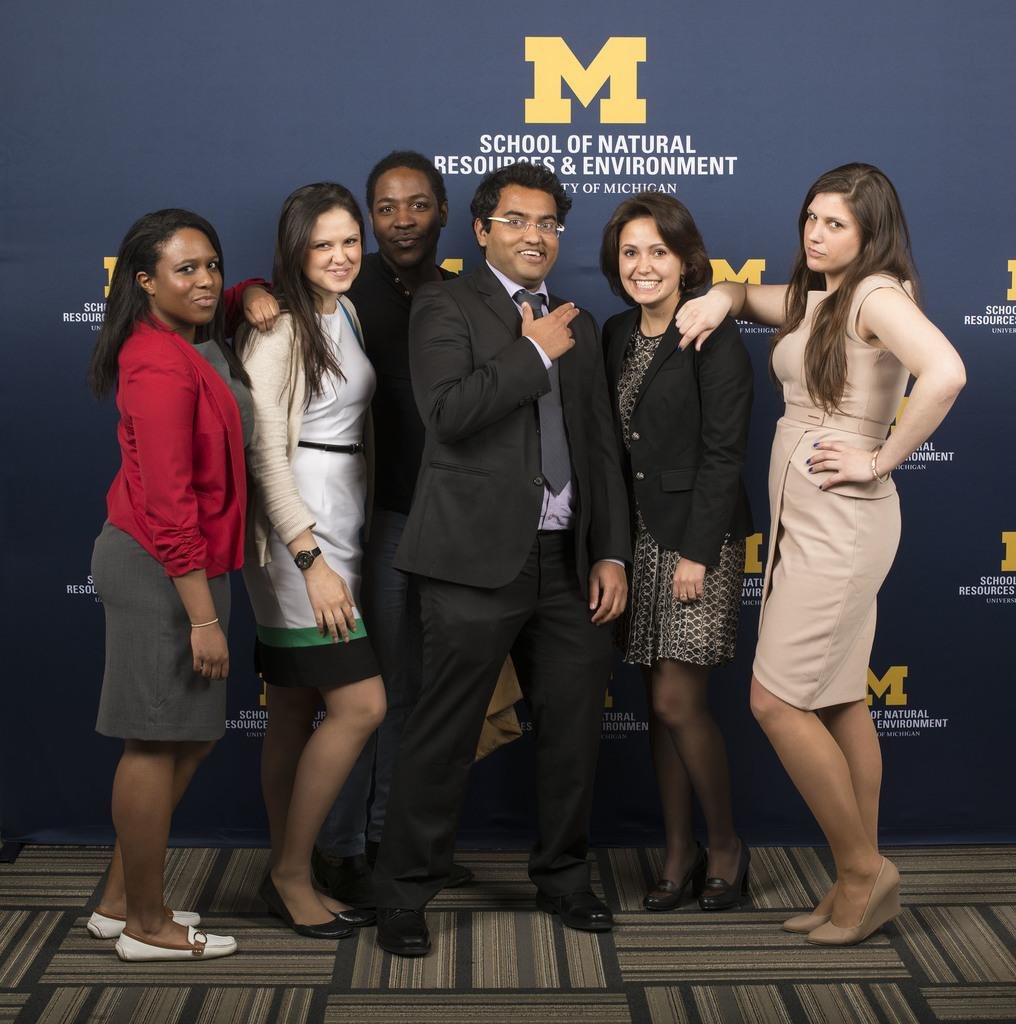What are the people in the image doing? The people in the image are standing on a mat. What is the facial expression of the people in the image? The people are smiling. What can be seen in the background of the image? There is a banner with text in the background of the image. Can you see a crown on the head of any person in the image? There is no crown visible on the head of any person in the image. What type of drum is being played by the people in the image? There are no drums present in the image; the people are simply standing on a mat and smiling. 